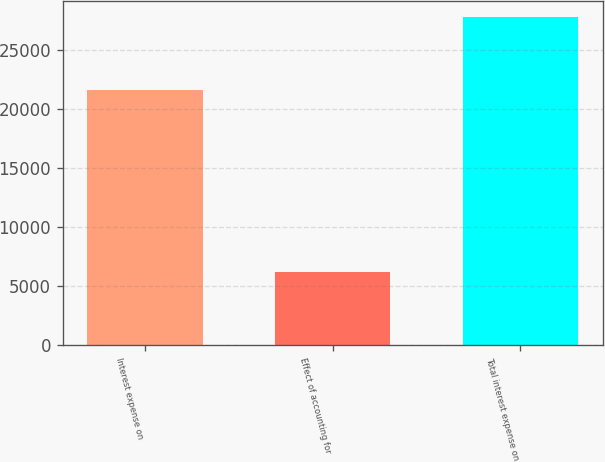Convert chart to OTSL. <chart><loc_0><loc_0><loc_500><loc_500><bar_chart><fcel>Interest expense on<fcel>Effect of accounting for<fcel>Total interest expense on<nl><fcel>21594<fcel>6151<fcel>27745<nl></chart> 